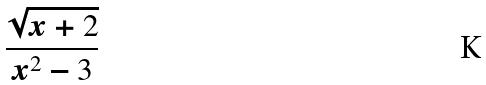Convert formula to latex. <formula><loc_0><loc_0><loc_500><loc_500>\frac { \sqrt { x + 2 } } { x ^ { 2 } - 3 }</formula> 